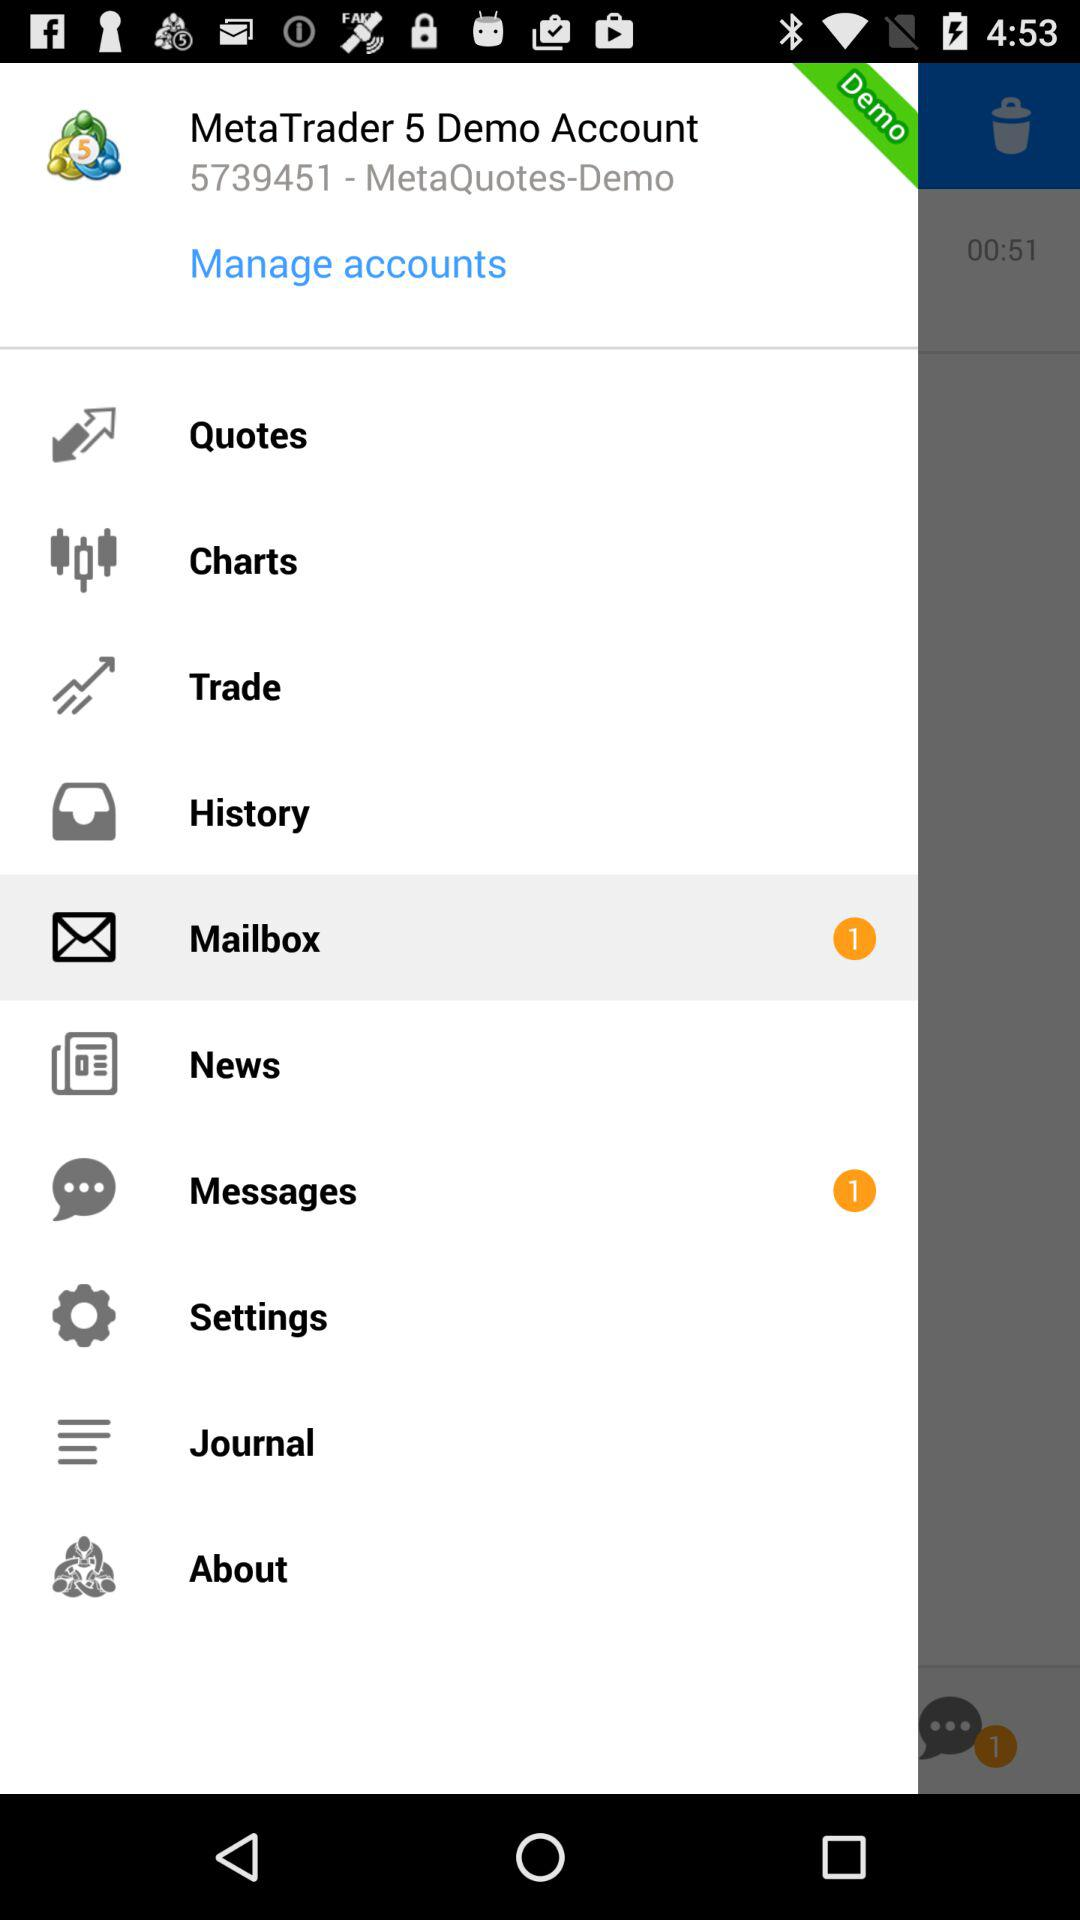How many items are in the main menu?
Answer the question using a single word or phrase. 10 